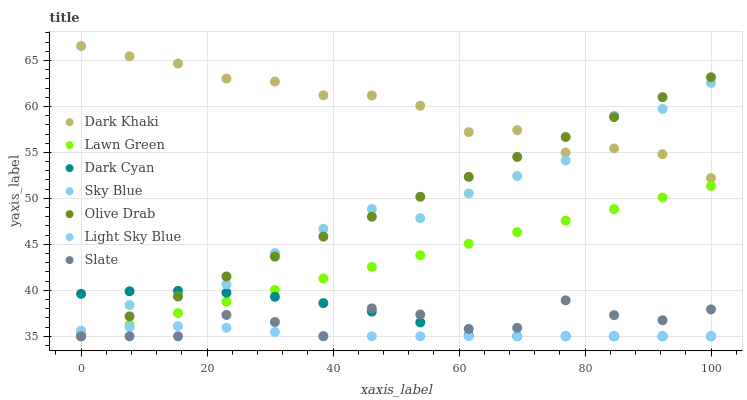Does Light Sky Blue have the minimum area under the curve?
Answer yes or no. Yes. Does Dark Khaki have the maximum area under the curve?
Answer yes or no. Yes. Does Slate have the minimum area under the curve?
Answer yes or no. No. Does Slate have the maximum area under the curve?
Answer yes or no. No. Is Olive Drab the smoothest?
Answer yes or no. Yes. Is Slate the roughest?
Answer yes or no. Yes. Is Dark Khaki the smoothest?
Answer yes or no. No. Is Dark Khaki the roughest?
Answer yes or no. No. Does Lawn Green have the lowest value?
Answer yes or no. Yes. Does Dark Khaki have the lowest value?
Answer yes or no. No. Does Dark Khaki have the highest value?
Answer yes or no. Yes. Does Slate have the highest value?
Answer yes or no. No. Is Lawn Green less than Dark Khaki?
Answer yes or no. Yes. Is Dark Khaki greater than Light Sky Blue?
Answer yes or no. Yes. Does Sky Blue intersect Light Sky Blue?
Answer yes or no. Yes. Is Sky Blue less than Light Sky Blue?
Answer yes or no. No. Is Sky Blue greater than Light Sky Blue?
Answer yes or no. No. Does Lawn Green intersect Dark Khaki?
Answer yes or no. No. 